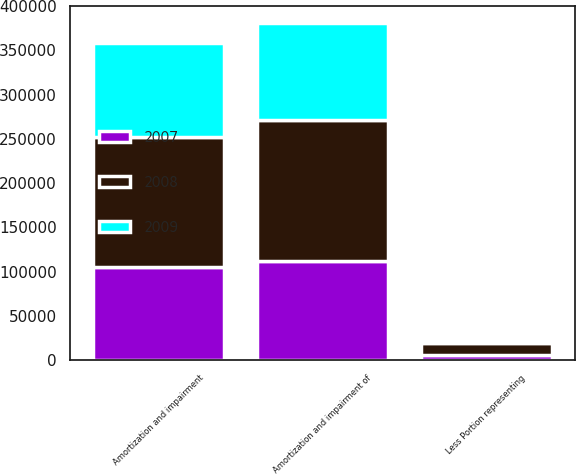Convert chart to OTSL. <chart><loc_0><loc_0><loc_500><loc_500><stacked_bar_chart><ecel><fcel>Amortization and impairment of<fcel>Less Portion representing<fcel>Amortization and impairment<nl><fcel>2007<fcel>111615<fcel>6094<fcel>105521<nl><fcel>2008<fcel>159563<fcel>13461<fcel>146102<nl><fcel>2009<fcel>109891<fcel>3216<fcel>106675<nl></chart> 